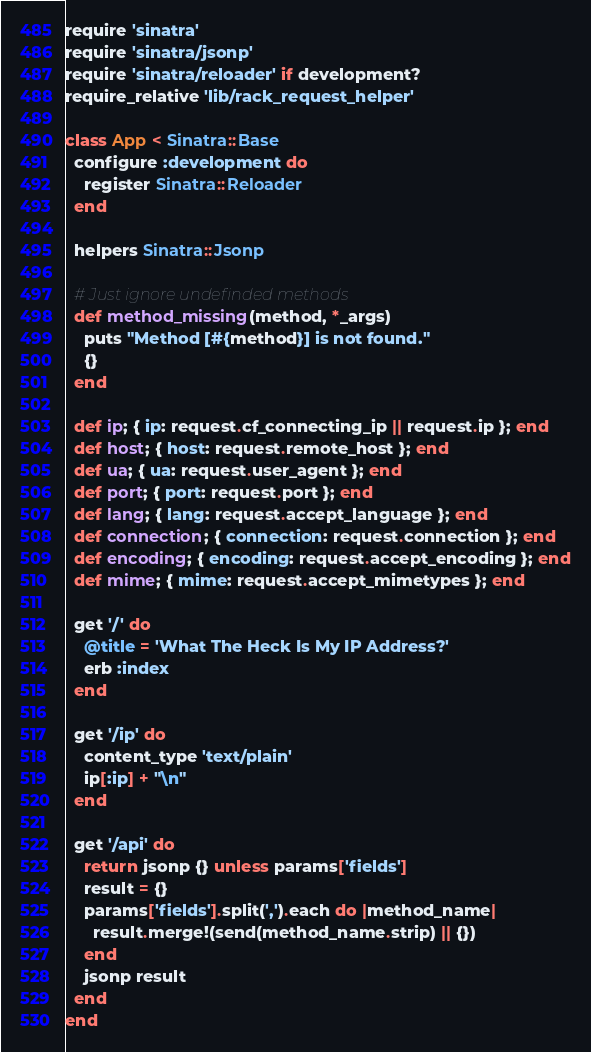Convert code to text. <code><loc_0><loc_0><loc_500><loc_500><_Ruby_>require 'sinatra'
require 'sinatra/jsonp'
require 'sinatra/reloader' if development?
require_relative 'lib/rack_request_helper'

class App < Sinatra::Base
  configure :development do
    register Sinatra::Reloader
  end

  helpers Sinatra::Jsonp

  # Just ignore undefinded methods
  def method_missing(method, *_args)
    puts "Method [#{method}] is not found."
    {}
  end

  def ip; { ip: request.cf_connecting_ip || request.ip }; end
  def host; { host: request.remote_host }; end
  def ua; { ua: request.user_agent }; end
  def port; { port: request.port }; end
  def lang; { lang: request.accept_language }; end
  def connection; { connection: request.connection }; end
  def encoding; { encoding: request.accept_encoding }; end
  def mime; { mime: request.accept_mimetypes }; end

  get '/' do
    @title = 'What The Heck Is My IP Address?'
    erb :index
  end

  get '/ip' do
    content_type 'text/plain'
    ip[:ip] + "\n"
  end

  get '/api' do
    return jsonp {} unless params['fields']
    result = {}
    params['fields'].split(',').each do |method_name|
      result.merge!(send(method_name.strip) || {})
    end
    jsonp result
  end
end
</code> 